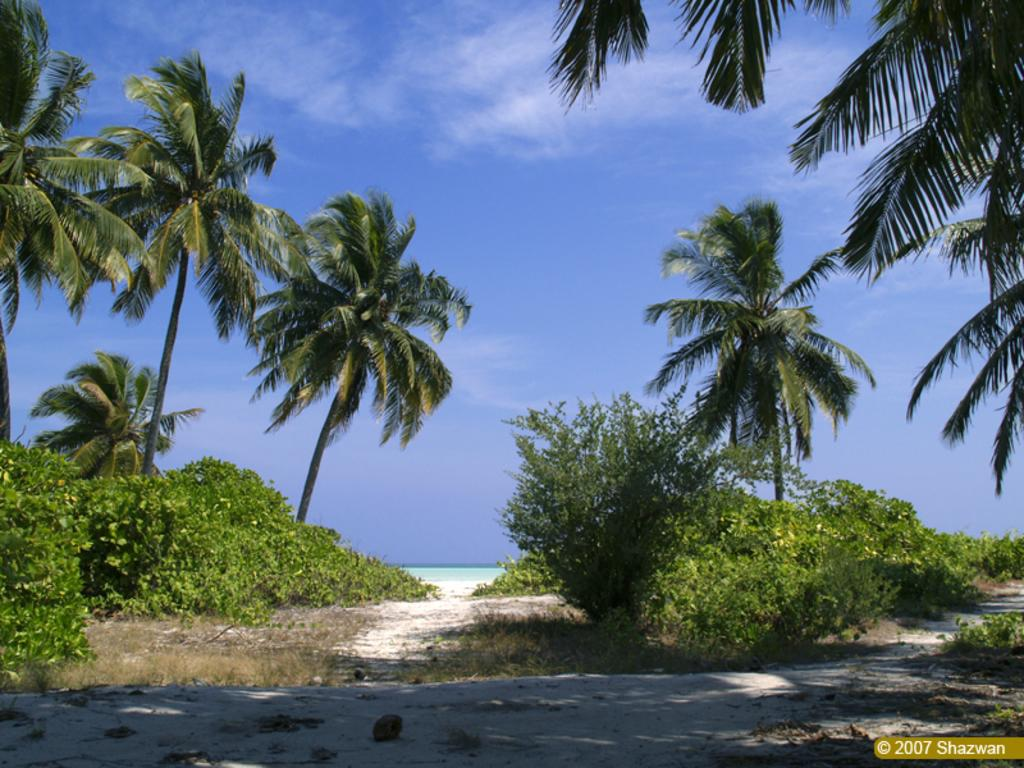What type of terrain is visible in the image? There is sand, grass, and plants visible in the image. What other natural elements can be seen in the image? There are trees and water visible in the image. What is visible in the background of the image? The sky is visible in the background of the image. Is there any indication of human intervention or modification in the image? Yes, there is a watermark on the image. What type of crown is worn by the tree in the image? There is no crown present in the image, and no tree is wearing any type of crown. How does the coat of pollution affect the plants in the image? There is no pollution present in the image, and therefore no coat of pollution affecting the plants. 